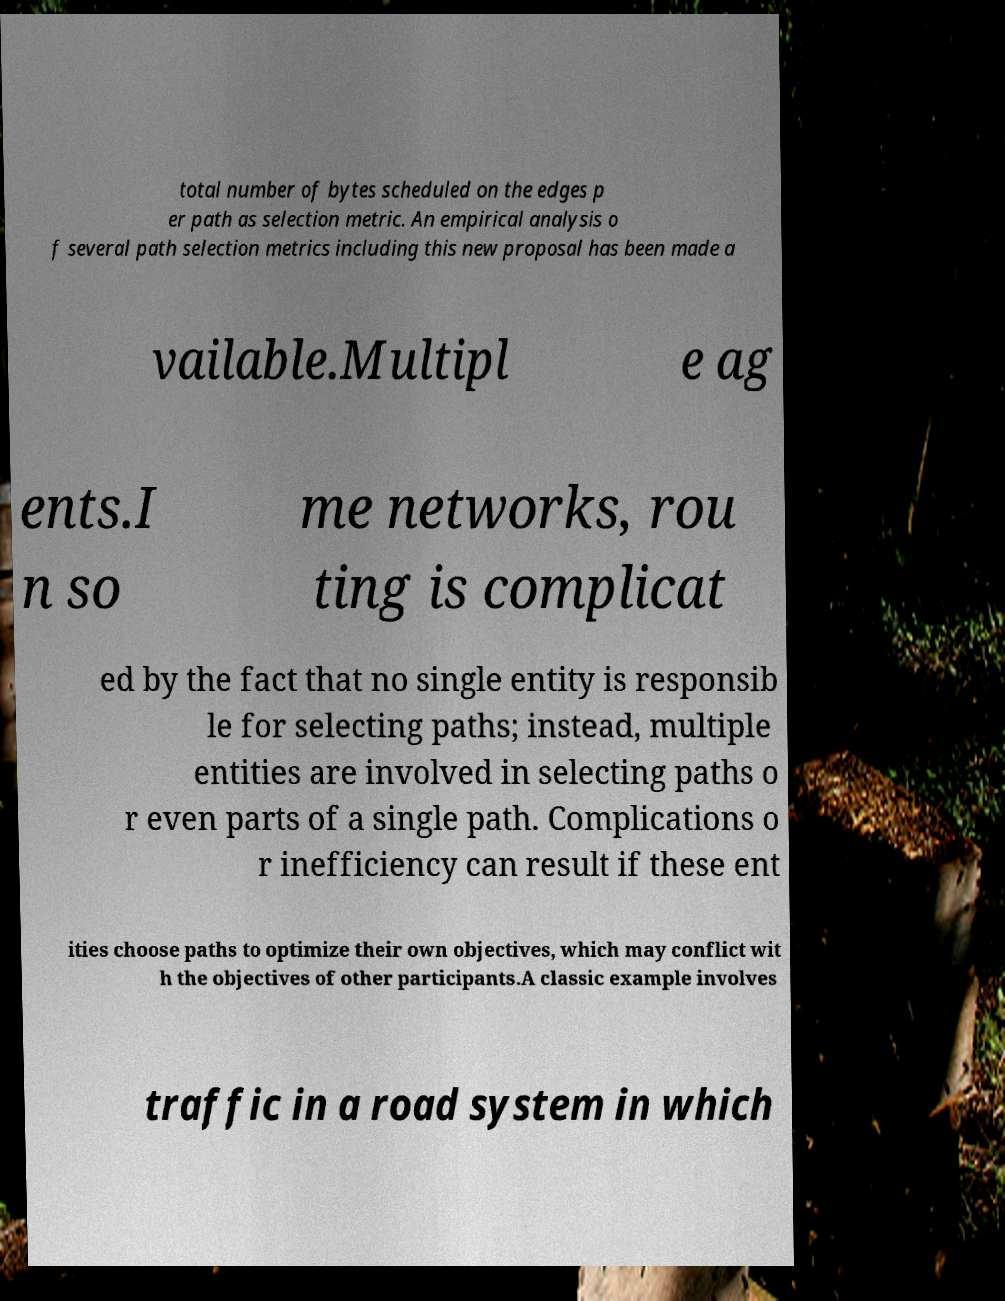For documentation purposes, I need the text within this image transcribed. Could you provide that? total number of bytes scheduled on the edges p er path as selection metric. An empirical analysis o f several path selection metrics including this new proposal has been made a vailable.Multipl e ag ents.I n so me networks, rou ting is complicat ed by the fact that no single entity is responsib le for selecting paths; instead, multiple entities are involved in selecting paths o r even parts of a single path. Complications o r inefficiency can result if these ent ities choose paths to optimize their own objectives, which may conflict wit h the objectives of other participants.A classic example involves traffic in a road system in which 